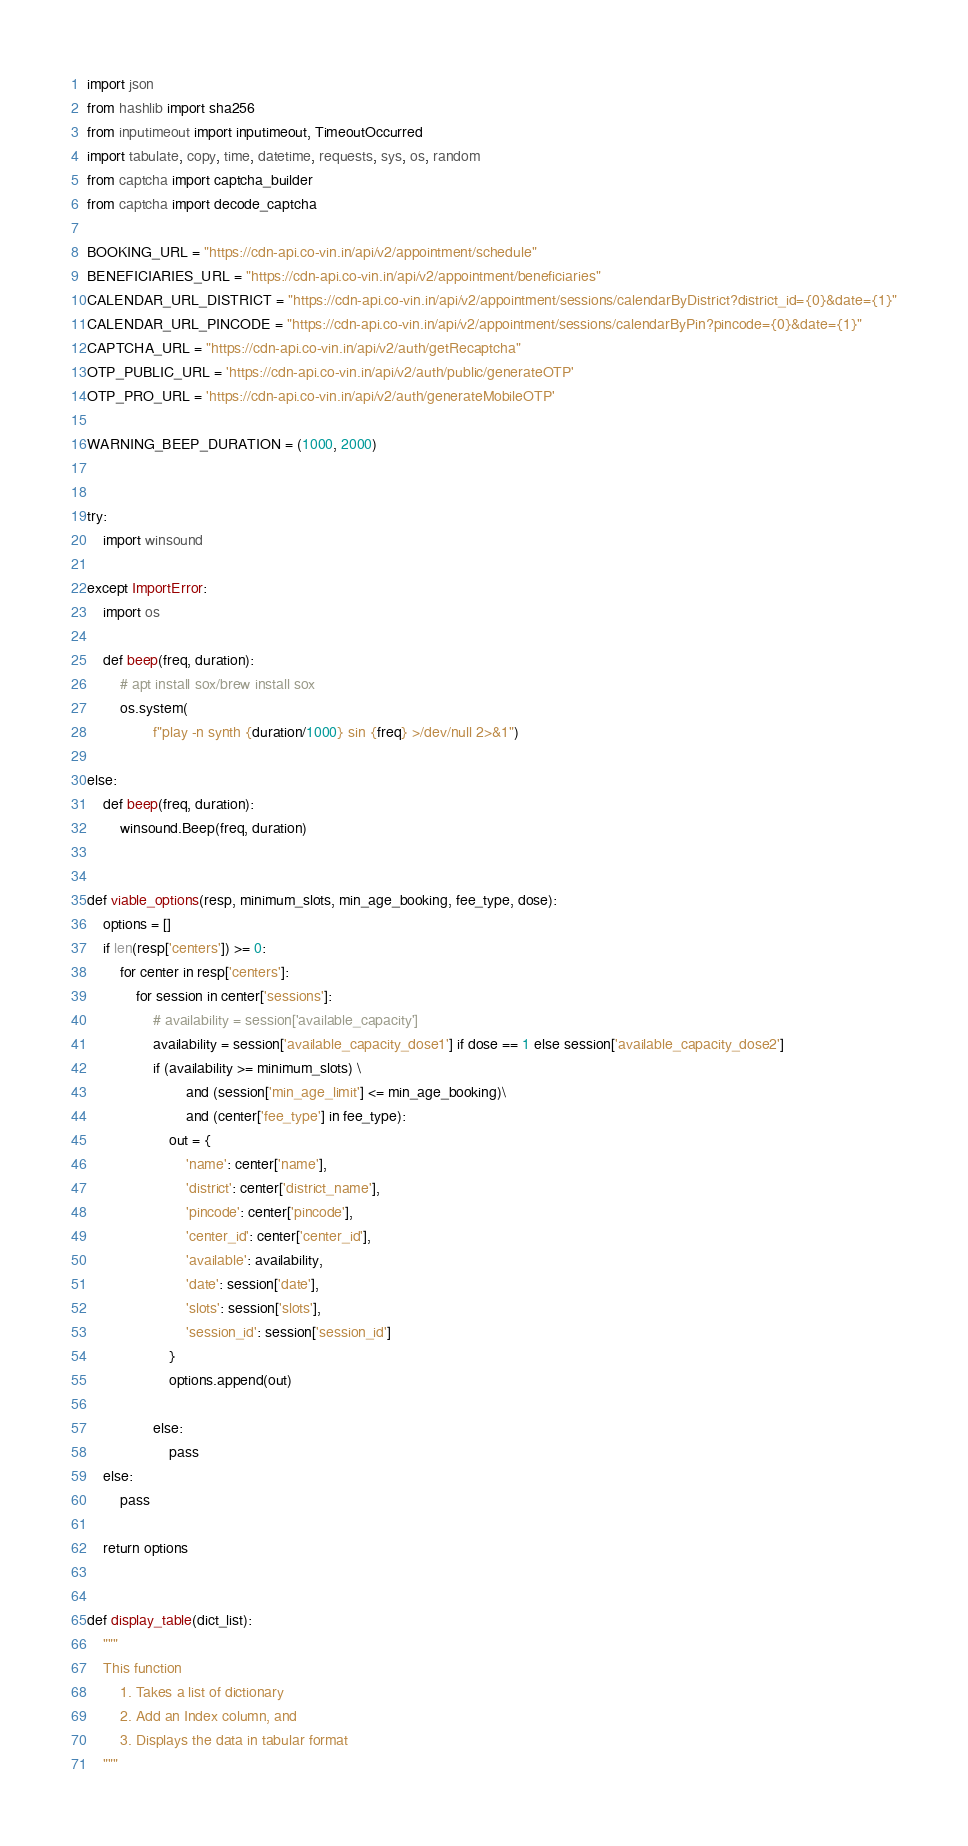<code> <loc_0><loc_0><loc_500><loc_500><_Python_>import json
from hashlib import sha256
from inputimeout import inputimeout, TimeoutOccurred
import tabulate, copy, time, datetime, requests, sys, os, random
from captcha import captcha_builder
from captcha import decode_captcha

BOOKING_URL = "https://cdn-api.co-vin.in/api/v2/appointment/schedule"
BENEFICIARIES_URL = "https://cdn-api.co-vin.in/api/v2/appointment/beneficiaries"
CALENDAR_URL_DISTRICT = "https://cdn-api.co-vin.in/api/v2/appointment/sessions/calendarByDistrict?district_id={0}&date={1}"
CALENDAR_URL_PINCODE = "https://cdn-api.co-vin.in/api/v2/appointment/sessions/calendarByPin?pincode={0}&date={1}"
CAPTCHA_URL = "https://cdn-api.co-vin.in/api/v2/auth/getRecaptcha"
OTP_PUBLIC_URL = 'https://cdn-api.co-vin.in/api/v2/auth/public/generateOTP'
OTP_PRO_URL = 'https://cdn-api.co-vin.in/api/v2/auth/generateMobileOTP'

WARNING_BEEP_DURATION = (1000, 2000)


try:
    import winsound

except ImportError:
    import os

    def beep(freq, duration):
        # apt install sox/brew install sox
        os.system(
                f"play -n synth {duration/1000} sin {freq} >/dev/null 2>&1")

else:
    def beep(freq, duration):
        winsound.Beep(freq, duration)


def viable_options(resp, minimum_slots, min_age_booking, fee_type, dose):
    options = []
    if len(resp['centers']) >= 0:
        for center in resp['centers']:
            for session in center['sessions']:
                # availability = session['available_capacity']
                availability = session['available_capacity_dose1'] if dose == 1 else session['available_capacity_dose2']
                if (availability >= minimum_slots) \
                        and (session['min_age_limit'] <= min_age_booking)\
                        and (center['fee_type'] in fee_type):
                    out = {
                        'name': center['name'],
                        'district': center['district_name'],
                        'pincode': center['pincode'],
                        'center_id': center['center_id'],
                        'available': availability,
                        'date': session['date'],
                        'slots': session['slots'],
                        'session_id': session['session_id']
                    }
                    options.append(out)

                else:
                    pass
    else:
        pass

    return options


def display_table(dict_list):
    """
    This function
        1. Takes a list of dictionary
        2. Add an Index column, and
        3. Displays the data in tabular format
    """</code> 